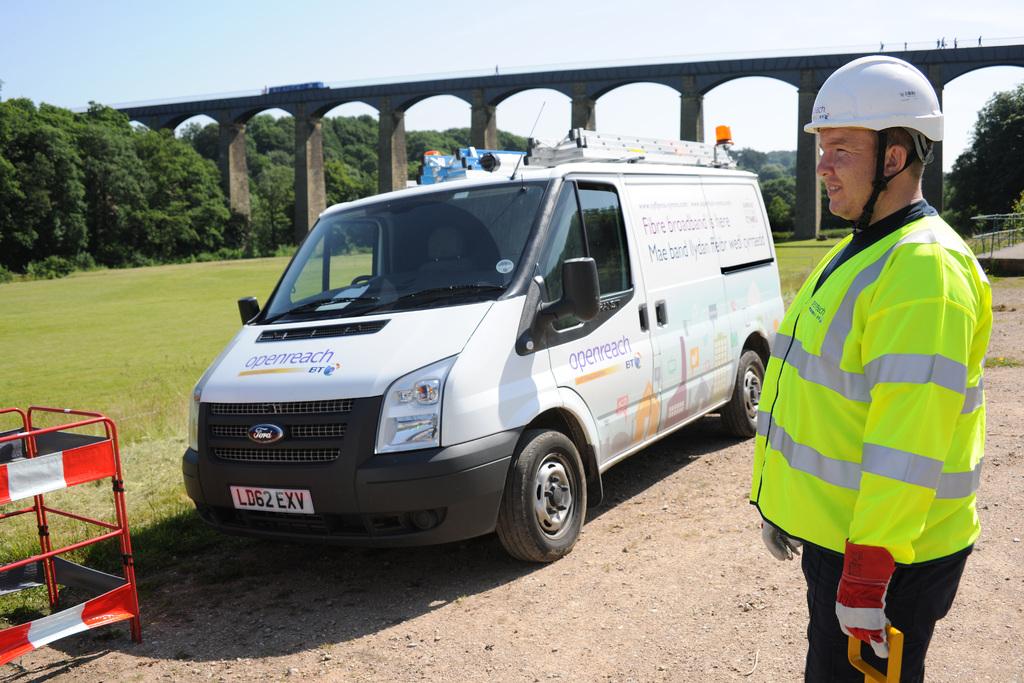Who makes the white van?
Offer a terse response. Ford. 